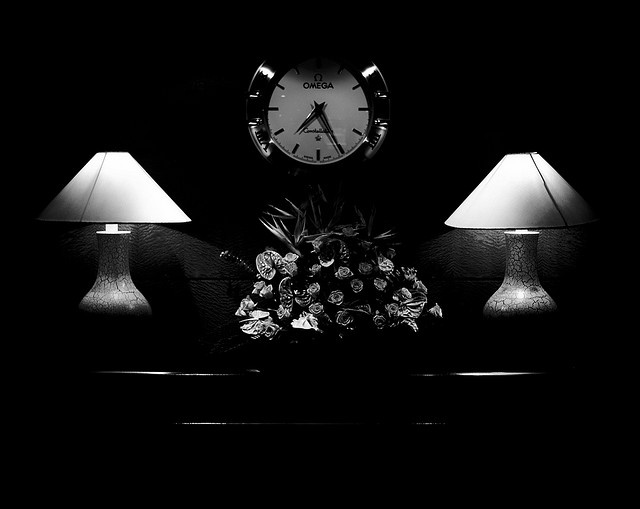Describe the objects in this image and their specific colors. I can see potted plant in black, gray, darkgray, and lightgray tones, clock in black, gray, and lightgray tones, and vase in black, gray, darkgray, and white tones in this image. 